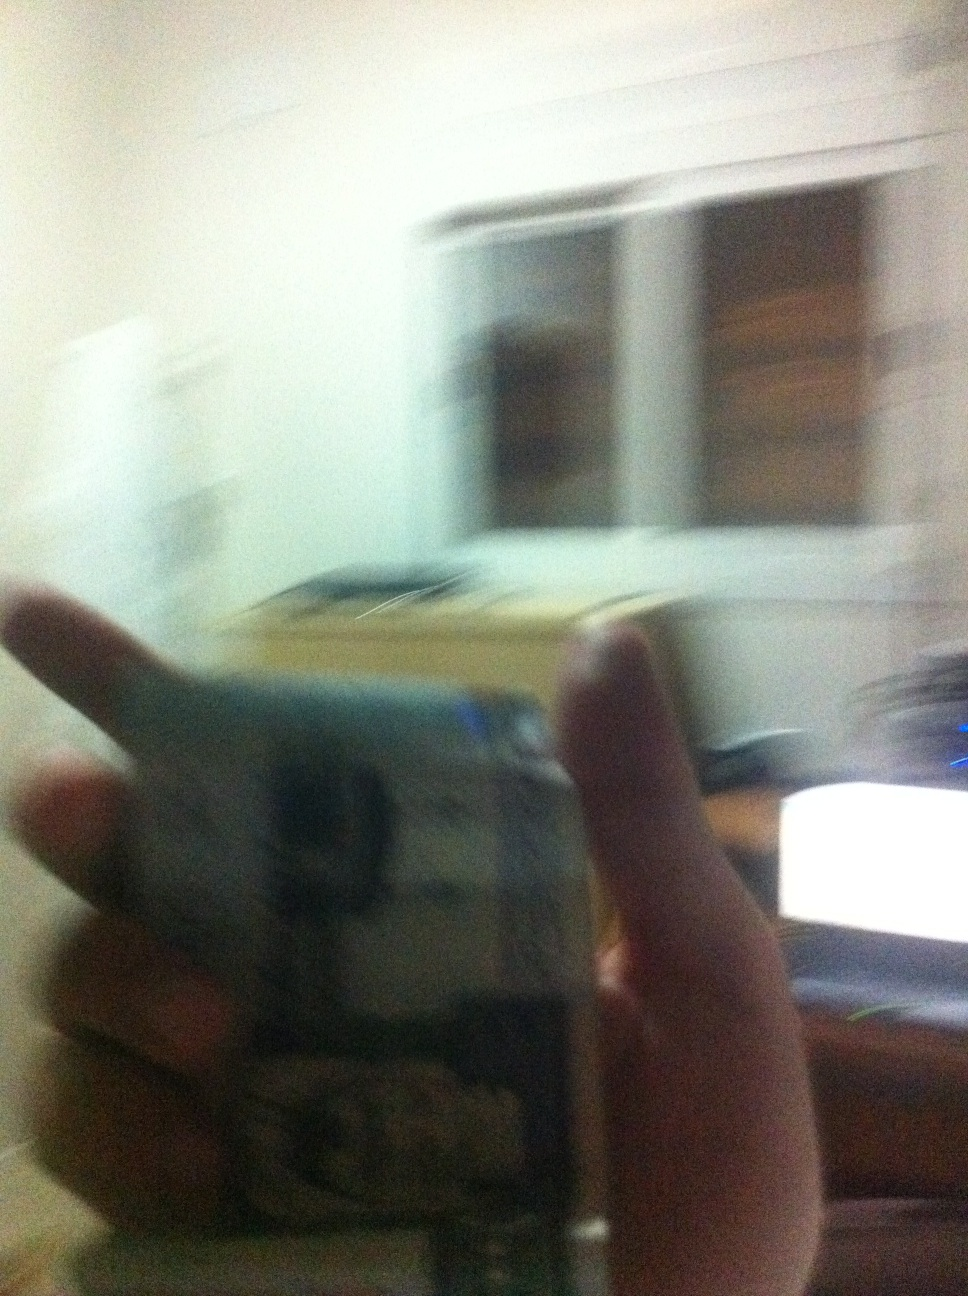Is it possible to determine the value of the currency in the image? The blurry nature of the image makes it impossible to accurately identify the value of the currency being held. A clearer image is required to make a precise identification. 